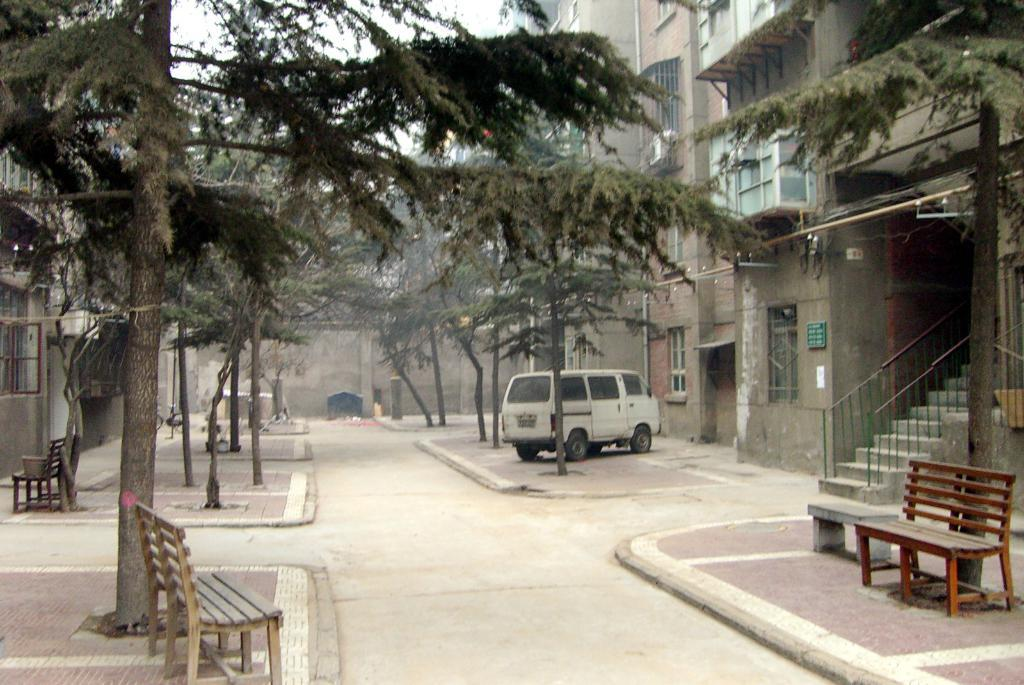What can be seen running through the image? There is a path in the image. What is located beside the path? A vehicle is parked beside the path. What type of seating is available along the path? There are benches on the footpath. What type of vegetation is present beside the footpath? Trees are present beside the footpath. What type of structure is visible in the image? There is a building with windows in the image. What is displayed on the building? There is a name board on the building. Can you tell me how many snails are crawling on the name board in the image? There are no snails present on the name board in the image. What type of change can be seen happening to the building in the image? There is no indication of any change happening to the building in the image. 